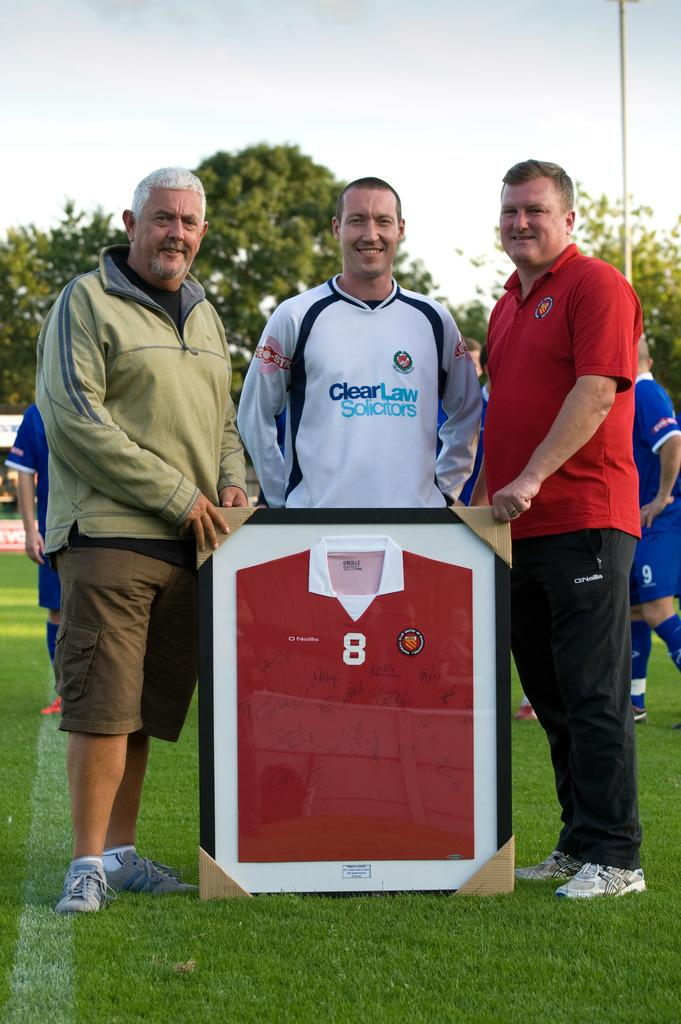<image>
Share a concise interpretation of the image provided. # guys standing on a field with a shirt in a frame and one guys shirt says Clear Law Solicitors 